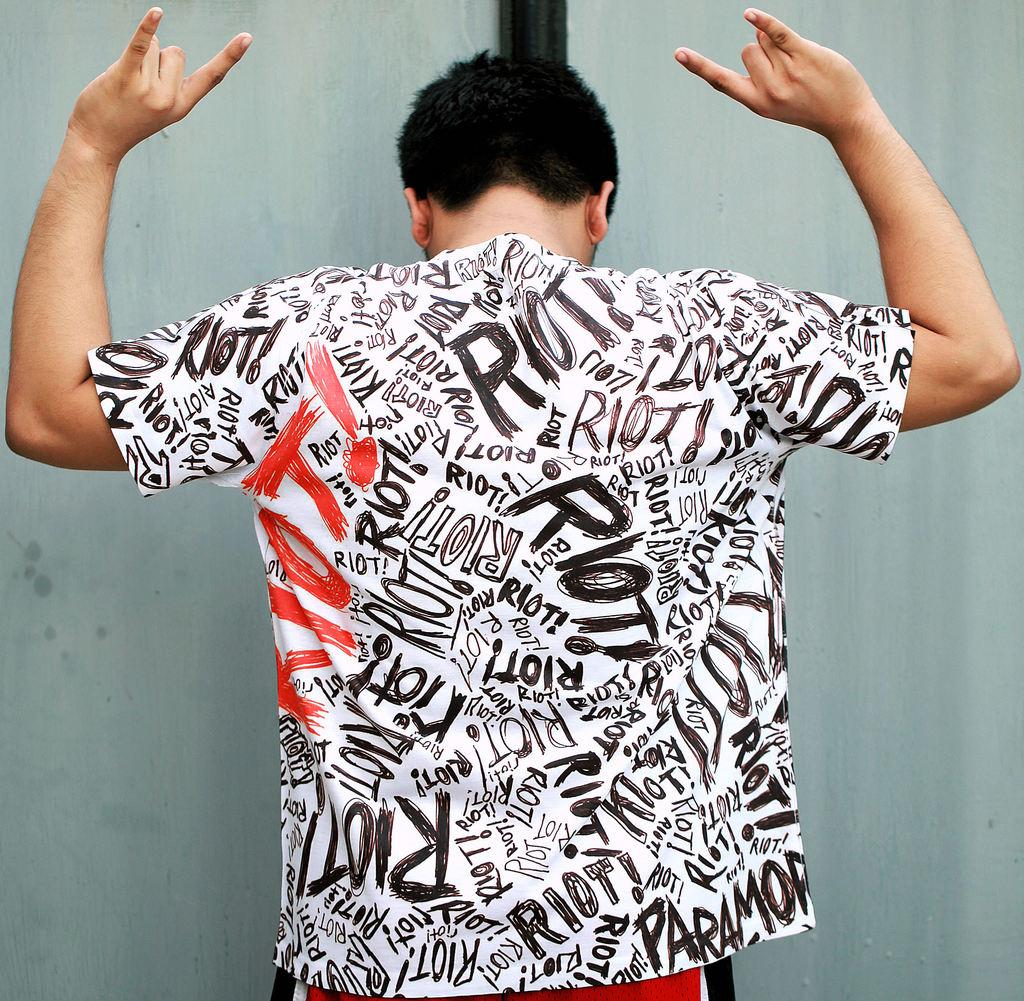<image>
Relay a brief, clear account of the picture shown. A man holds his hands in the air while wearing a shirt with the word riot written on it over and over again in a messy font. 